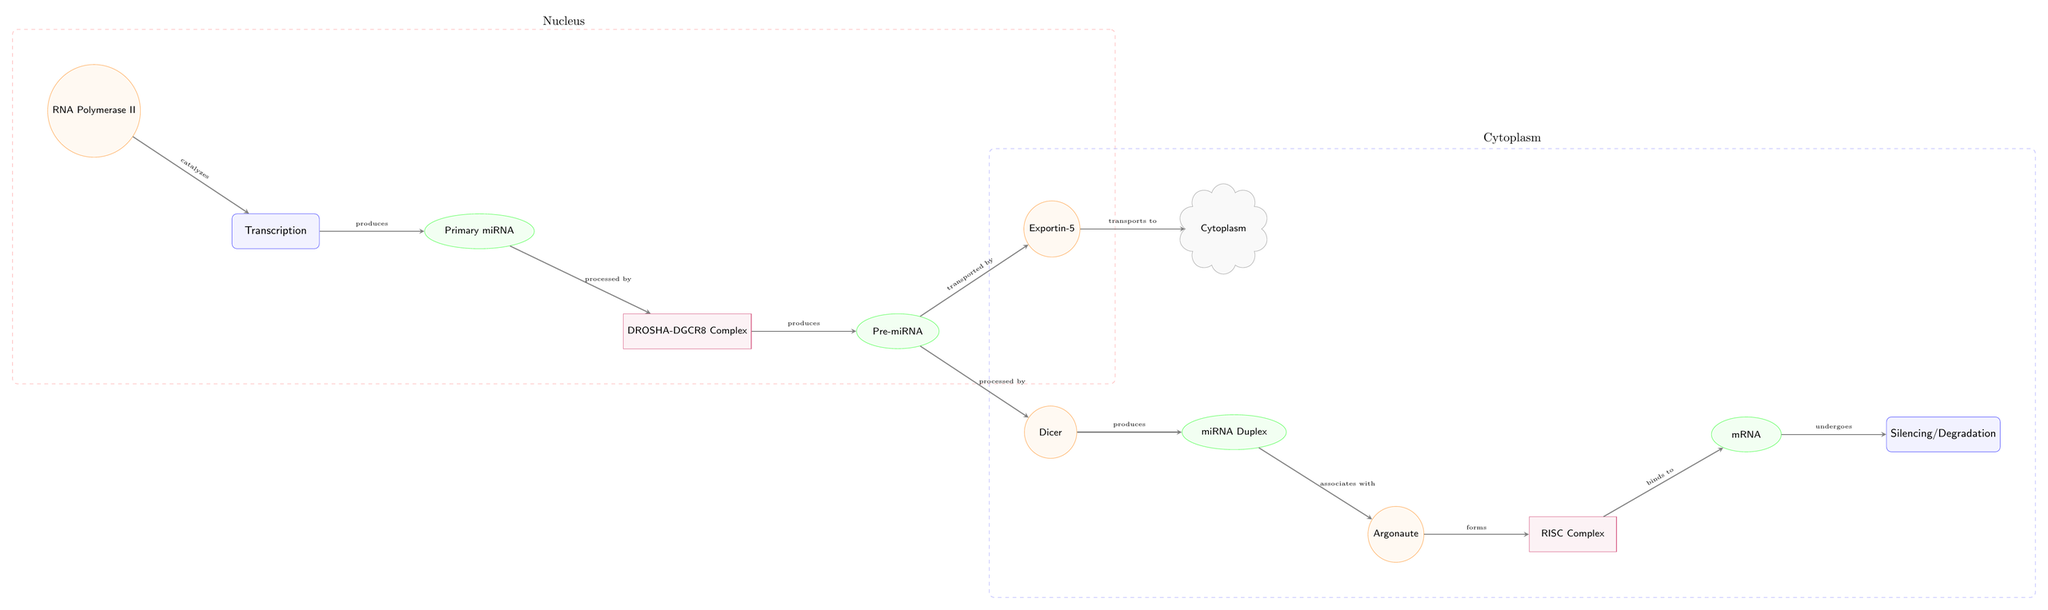What's the role of RNA Polymerase II in the diagram? The arrow from RNA Polymerase II points to the Transcription node, indicating that it catalyzes the process of transcription, which is the first step in producing primary miRNA.
Answer: catalyzes How many molecular processes are depicted in the diagram? The diagram shows four main processes: Transcription, Silencing/Degradation, and the processing of pri-miRNA to pre-miRNA and then to miRNA Duplex. Counting these provides a total of four distinct processes.
Answer: 4 What does Exportin-5 do in the pathway? The arrow between Pre-miRNA and Exportin-5 indicates that Exportin-5 is responsible for transporting the pre-miRNA from the nucleus to the cytoplasm.
Answer: transports to cytoplasm Which protein complex is involved in the processing of pri-miRNA? The diagram shows the DROSHA-DGCR8 Complex processing the primary miRNA into pre-miRNA, as indicated by the arrow pointing from pri-miRNA to the complex.
Answer: DROSHA-DGCR8 Complex After the formation of the RISC Complex, what is the next step? The RISC Complex binds to mRNA according to the arrow leading from RISC to mRNA in the diagram. This indicates that the next step after RISC formation is the binding to mRNA.
Answer: binds to mRNA How many molecules are involved in the final stage of silencing? In the last steps, the diagram shows only one molecule, mRNA, that undergoes Silencing/Degradation. Since all pathways eventually lead to this node, the answer is one.
Answer: 1 What is the relationship between Pre-miRNA and Dicer? The diagram indicates that Dicer processes Pre-miRNA into miRNA Duplex, as shown by the arrow pointing from Pre-miRNA to Dicer, followed by another arrow leading to miRNA Duplex.
Answer: processed by What cellular component is indicated for where Dicer operates? The diagram shows Dicer is positioned in the Cytoplasm, marked clearly by the adjacent cellular component node connected by an arrow from Pre-miRNA.
Answer: Cytoplasm Which process leads to the generation of miRNA Duplex? The diagram illustrates that the processing of Pre-miRNA by Dicer is the step that results in the production of the miRNA Duplex, as indicated by the arrows leading from Pre-miRNA to Dicer and then to miRNA Duplex.
Answer: produced by Dicer 